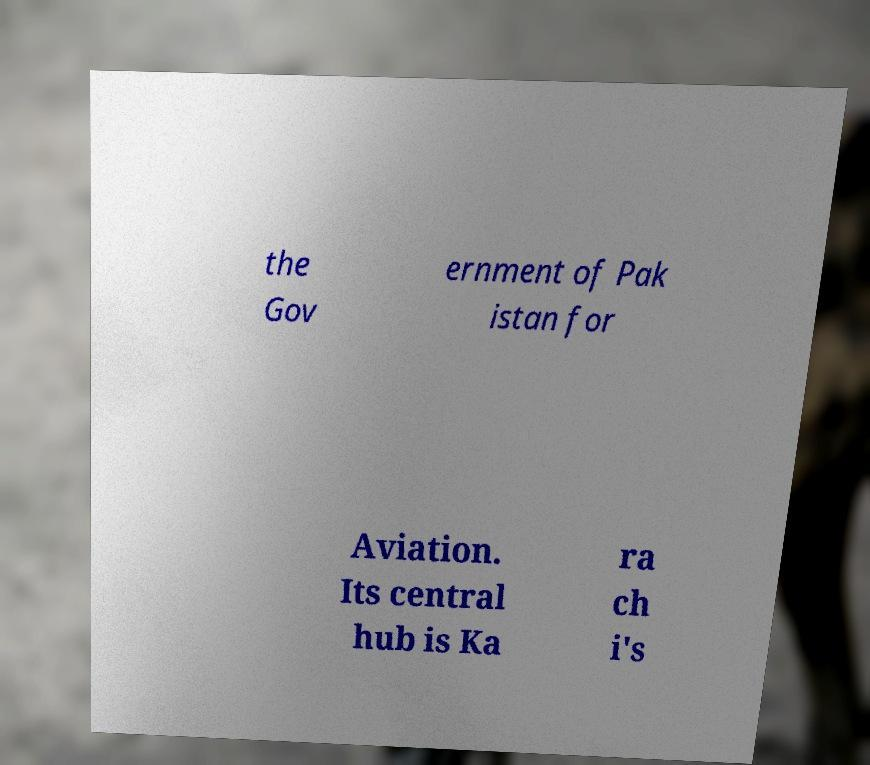Please read and relay the text visible in this image. What does it say? the Gov ernment of Pak istan for Aviation. Its central hub is Ka ra ch i's 